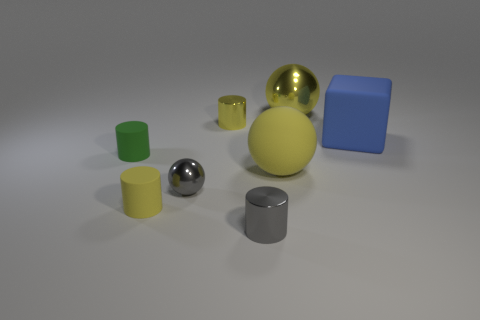Subtract all gray shiny cylinders. How many cylinders are left? 3 Subtract 1 balls. How many balls are left? 2 Subtract all green cylinders. How many cylinders are left? 3 Add 1 tiny shiny objects. How many objects exist? 9 Subtract all brown cylinders. Subtract all gray cubes. How many cylinders are left? 4 Subtract all blocks. How many objects are left? 7 Add 3 gray things. How many gray things exist? 5 Subtract 1 gray cylinders. How many objects are left? 7 Subtract all yellow rubber balls. Subtract all tiny things. How many objects are left? 2 Add 2 yellow matte objects. How many yellow matte objects are left? 4 